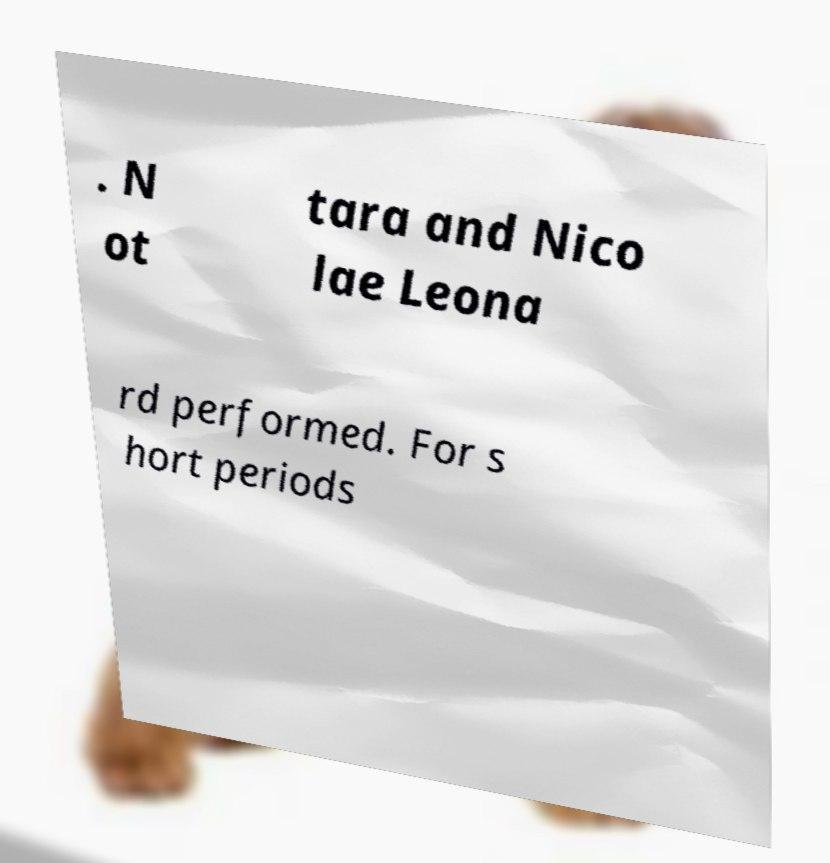Could you extract and type out the text from this image? . N ot tara and Nico lae Leona rd performed. For s hort periods 